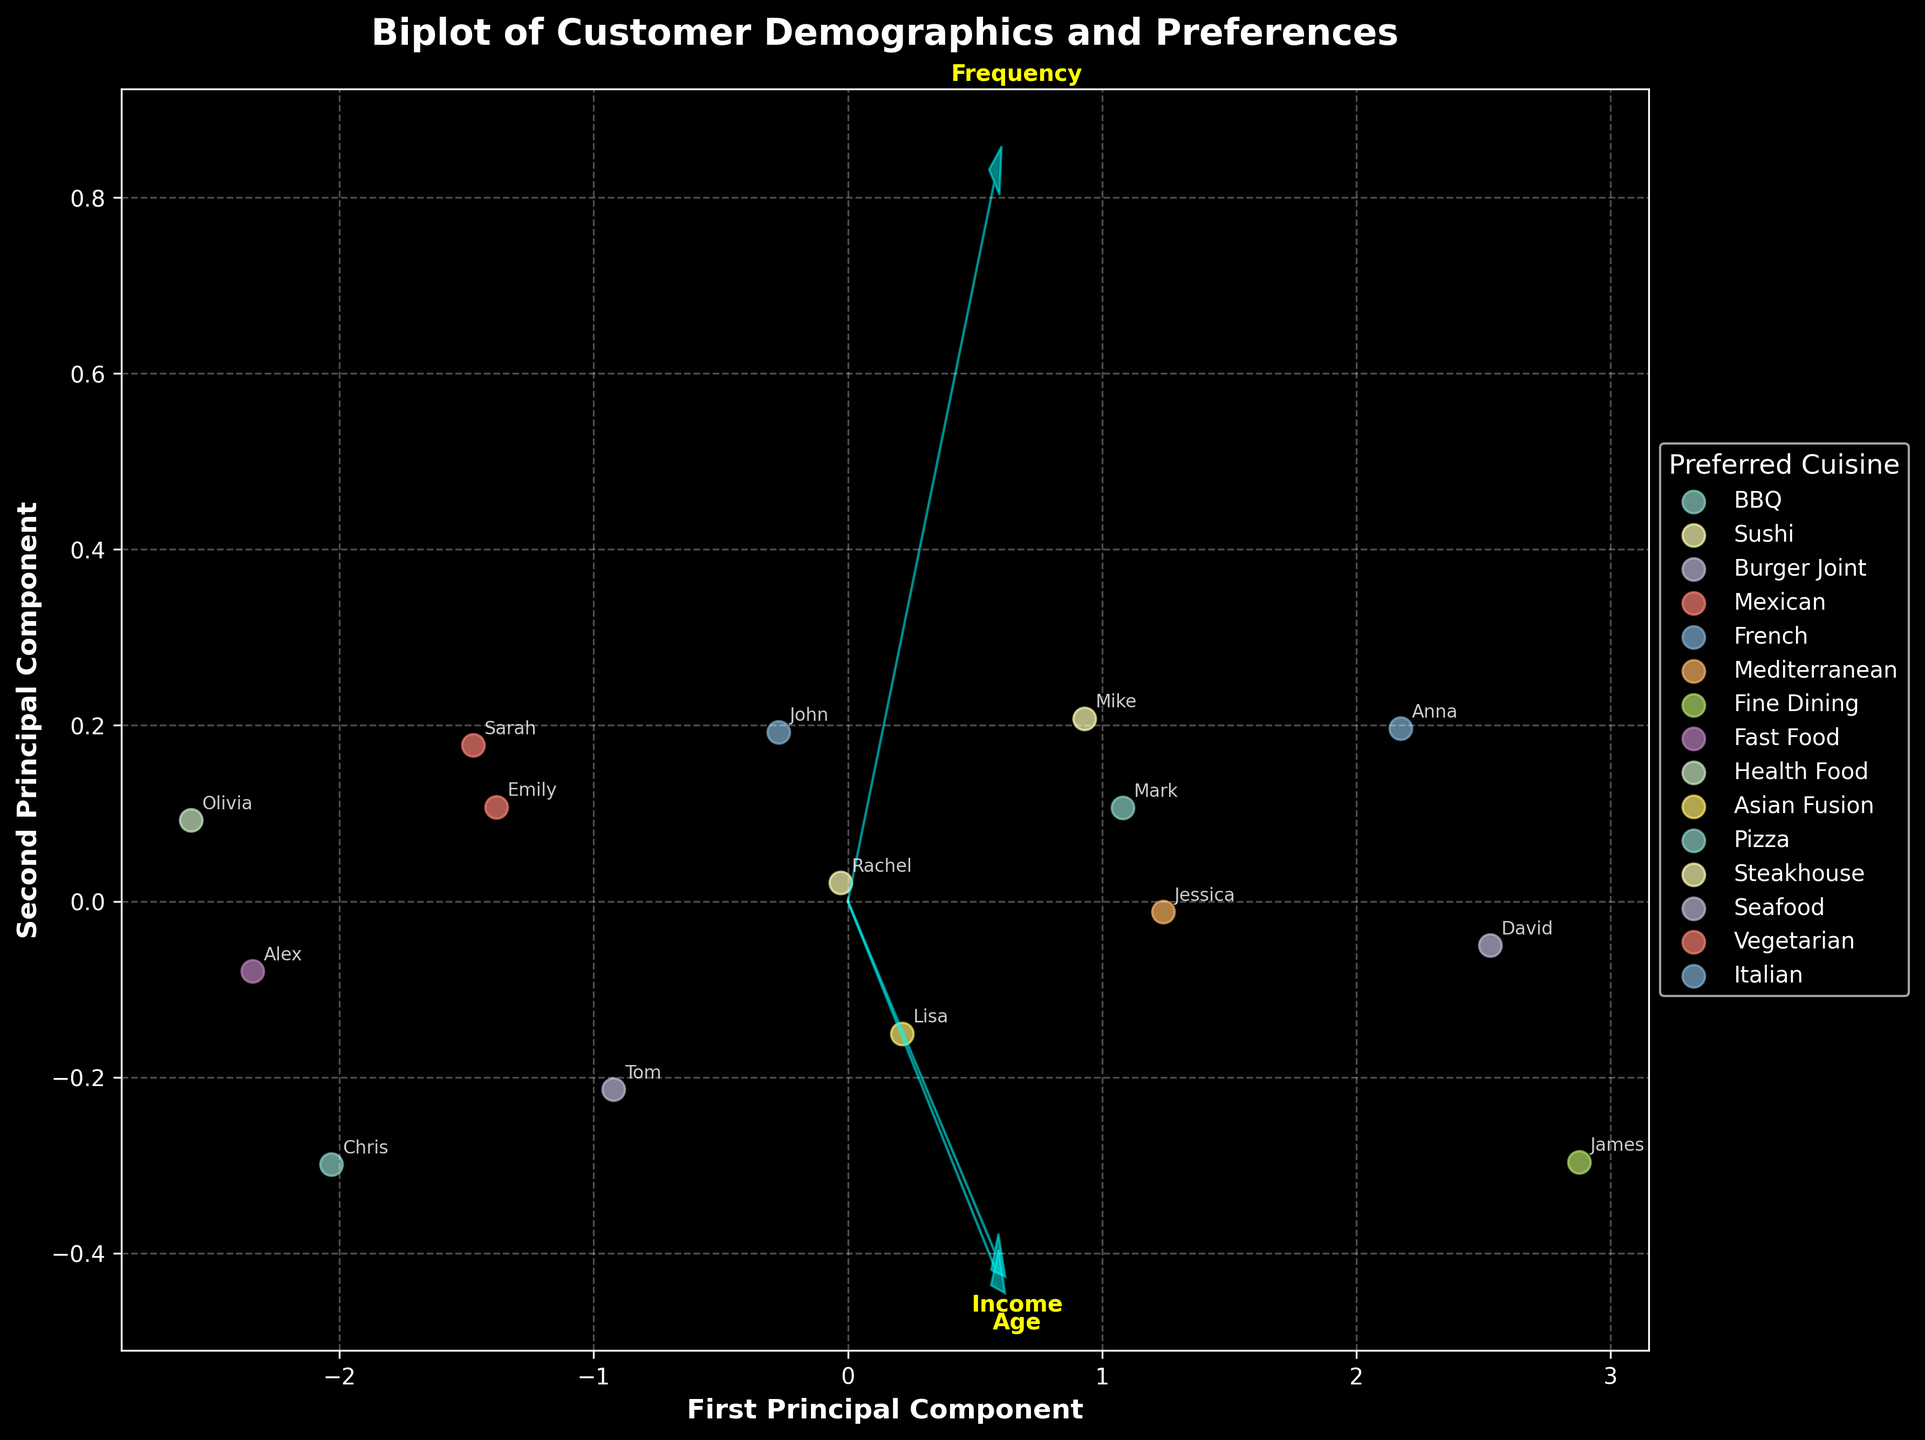What's the title of the figure? The title is found at the top of the figure and usually describes what the figure is about. In this case, the title is directly stated in the code provided.
Answer: Biplot of Customer Demographics and Preferences Which axis represents the First Principal Component? The axes are labeled in the figure. The x-axis is labeled 'First Principal Component' which indicates it represents the First Principal Component.
Answer: x-axis How many different preferred cuisines are represented in the plot? Each preferred cuisine is represented by a distinct scatter plot marker with a corresponding label in the legend. Counting the unique labels in the legend will give the answer.
Answer: 15 Which cuisine has the highest frequency according to the plot? The plot shows different points representing different cuisines. To find the one with the highest frequency, locate the cuisine point positioned farthest along the direction of the Frequency arrow.
Answer: Seafood What is the relation between income and the first principal component? Check the direction and length of the arrow corresponding to income. A longer arrow more aligned with the first principal component indicates a strong relation. The arrow for income points mostly along the x-axis (First Principal Component), suggesting a positive relation.
Answer: Positive relation Which two customers' preferences are closest to each other in the plot? Find the two data points that are plotted closest to each other in the figure. This will show the customers with similar preferences and demographics.
Answer: Sarah and Chris Which feature has the least influence on the first principal component? The length of the arrows in the plot shows the influence of features. The shorter the arrow along the first principal component axis, the less the influence.
Answer: Frequency Do younger customers prefer healthy cuisine or fast food more according to the plot? Locate the arrows showing the direction of Age and then find the clustered points. Younger customers' data points fall close to the ‘Health Food’ and ‘Fast Food’ regions, based on the annotations for Olivia and Alex.
Answer: Fast food Which customer has the highest age value according to the plot? Look for the arrow labeled Age and identify the customer point plotted farthest in that direction. According to the annotations, the farthest point in the direction of Age is James.
Answer: James Is income more related to the first principal component or the second? Check the projection of the Income arrow on first and second principal components. Since the Income arrow is more aligned with the first principal component (x-axis), it shows a stronger relation.
Answer: First principal component 